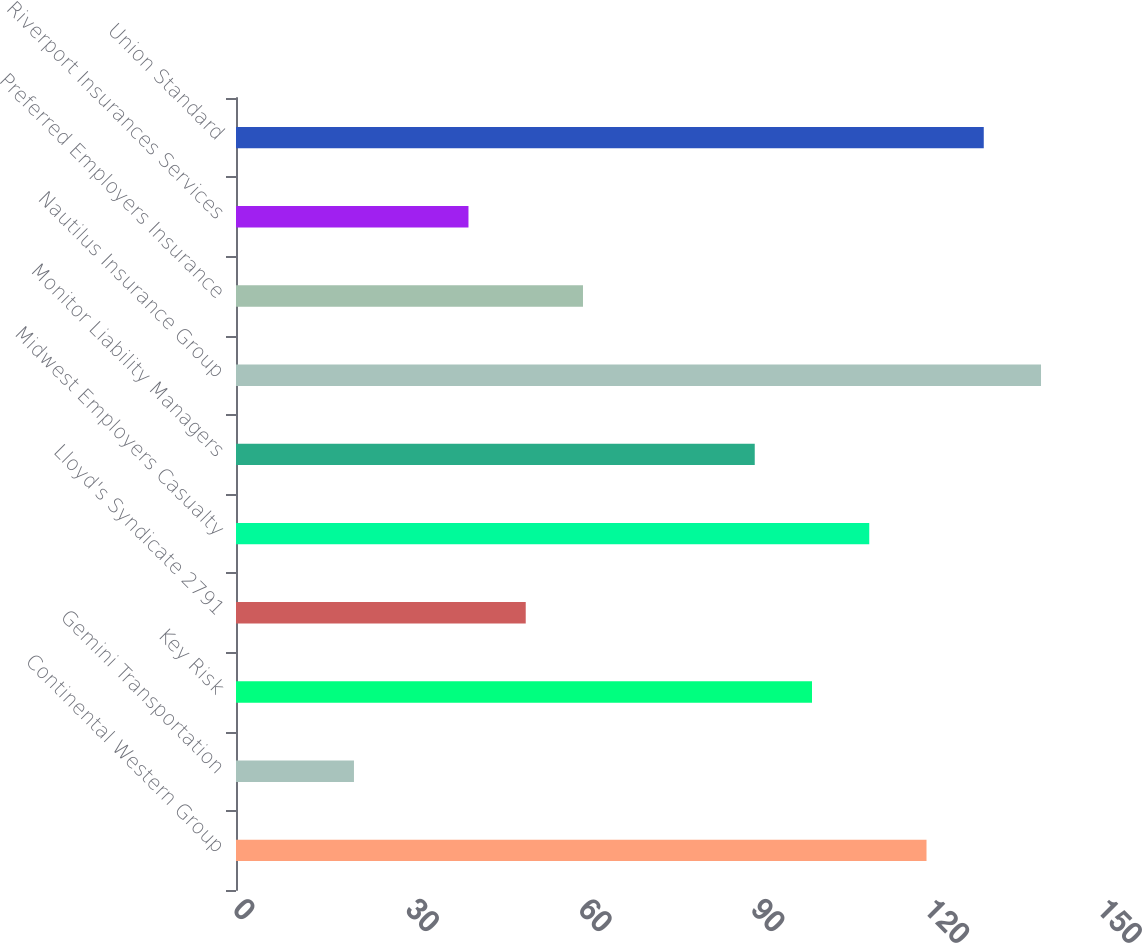Convert chart to OTSL. <chart><loc_0><loc_0><loc_500><loc_500><bar_chart><fcel>Continental Western Group<fcel>Gemini Transportation<fcel>Key Risk<fcel>Lloyd's Syndicate 2791<fcel>Midwest Employers Casualty<fcel>Monitor Liability Managers<fcel>Nautilus Insurance Group<fcel>Preferred Employers Insurance<fcel>Riverport Insurances Services<fcel>Union Standard<nl><fcel>119.88<fcel>20.48<fcel>100<fcel>50.3<fcel>109.94<fcel>90.06<fcel>139.76<fcel>60.24<fcel>40.36<fcel>129.82<nl></chart> 